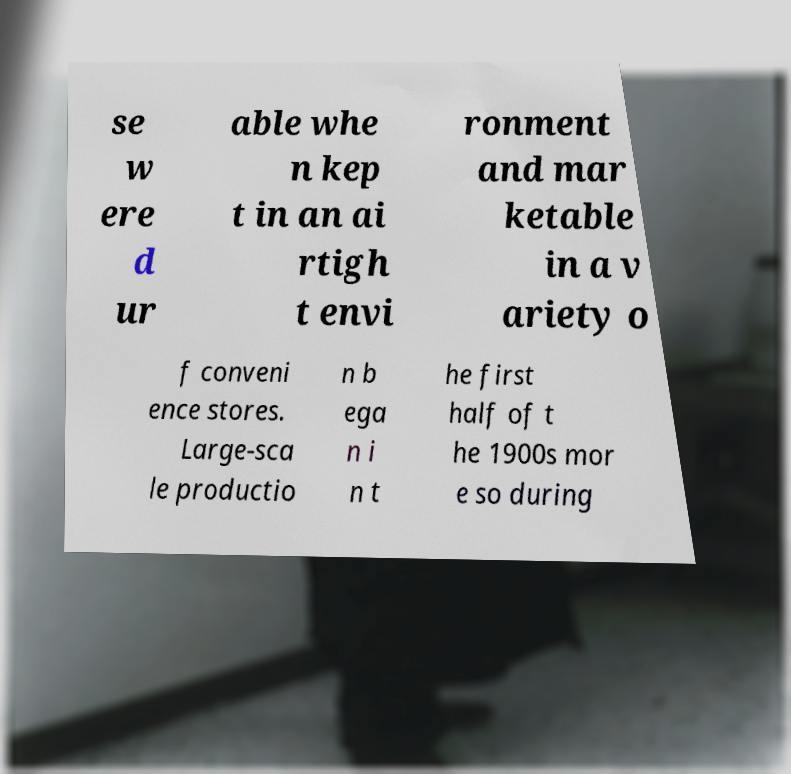Can you read and provide the text displayed in the image?This photo seems to have some interesting text. Can you extract and type it out for me? se w ere d ur able whe n kep t in an ai rtigh t envi ronment and mar ketable in a v ariety o f conveni ence stores. Large-sca le productio n b ega n i n t he first half of t he 1900s mor e so during 